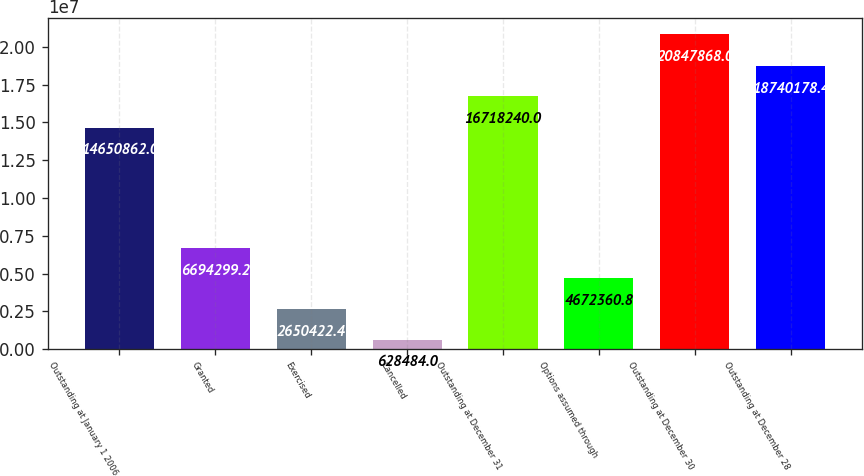Convert chart to OTSL. <chart><loc_0><loc_0><loc_500><loc_500><bar_chart><fcel>Outstanding at January 1 2006<fcel>Granted<fcel>Exercised<fcel>Cancelled<fcel>Outstanding at December 31<fcel>Options assumed through<fcel>Outstanding at December 30<fcel>Outstanding at December 28<nl><fcel>1.46509e+07<fcel>6.6943e+06<fcel>2.65042e+06<fcel>628484<fcel>1.67182e+07<fcel>4.67236e+06<fcel>2.08479e+07<fcel>1.87402e+07<nl></chart> 